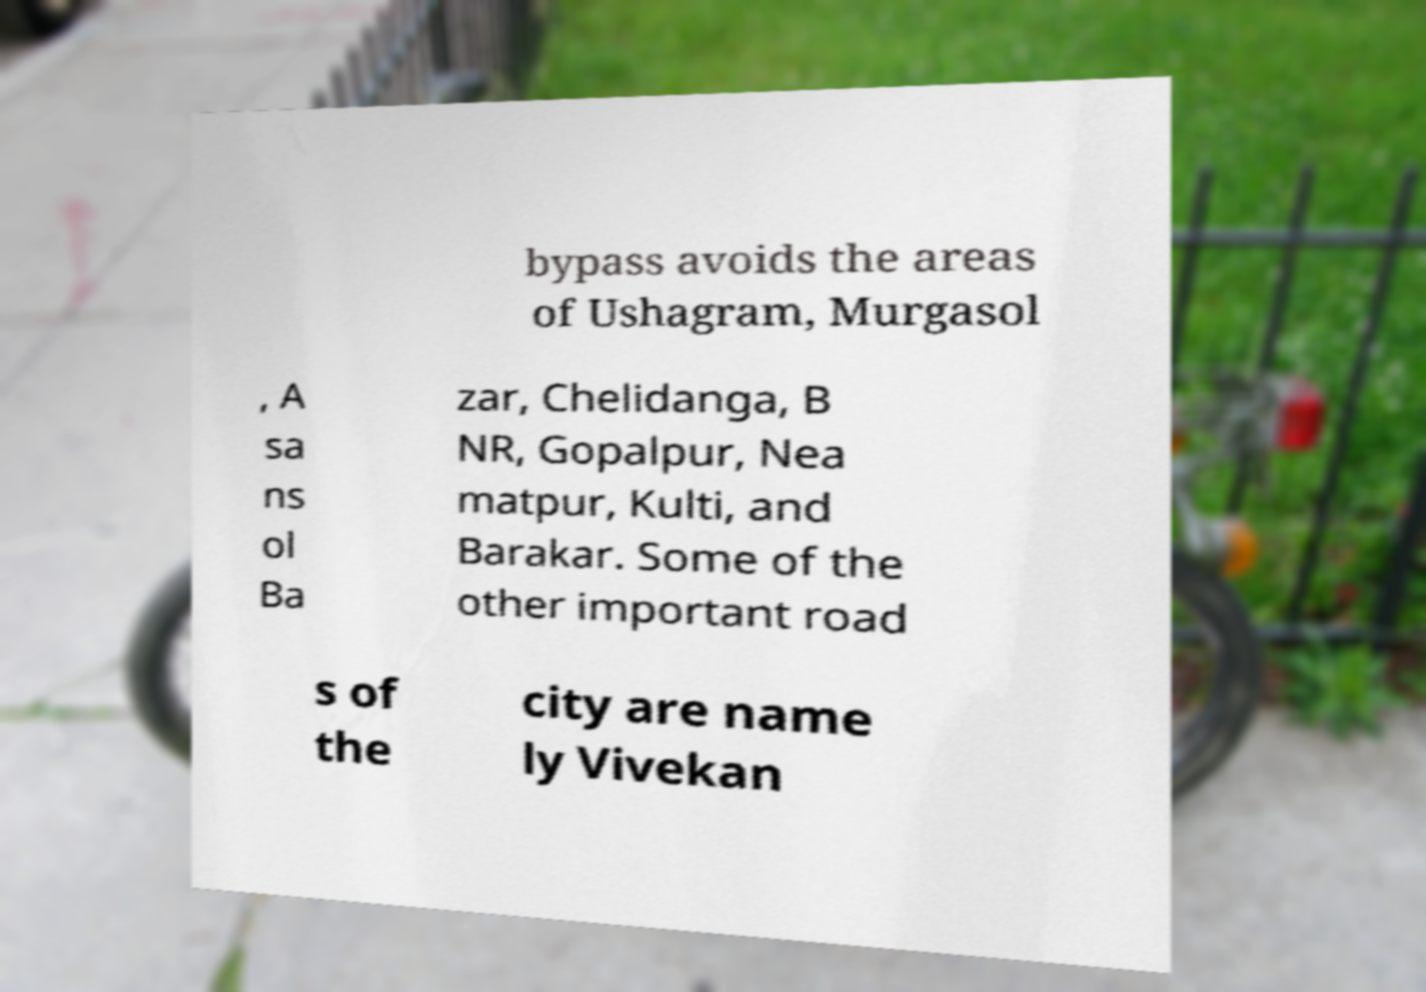Could you assist in decoding the text presented in this image and type it out clearly? bypass avoids the areas of Ushagram, Murgasol , A sa ns ol Ba zar, Chelidanga, B NR, Gopalpur, Nea matpur, Kulti, and Barakar. Some of the other important road s of the city are name ly Vivekan 